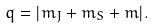<formula> <loc_0><loc_0><loc_500><loc_500>q = | m _ { J } + m _ { S } + m | .</formula> 